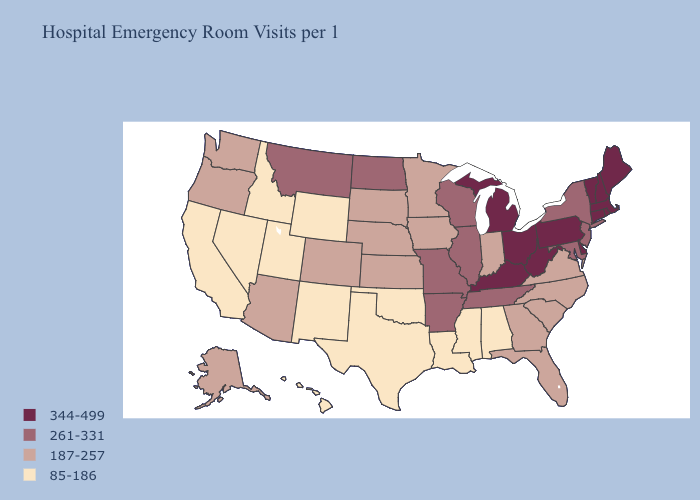Is the legend a continuous bar?
Be succinct. No. What is the value of Minnesota?
Answer briefly. 187-257. Does New York have the lowest value in the USA?
Quick response, please. No. Is the legend a continuous bar?
Quick response, please. No. Does the first symbol in the legend represent the smallest category?
Concise answer only. No. Does the first symbol in the legend represent the smallest category?
Short answer required. No. Name the states that have a value in the range 344-499?
Be succinct. Connecticut, Delaware, Kentucky, Maine, Massachusetts, Michigan, New Hampshire, Ohio, Pennsylvania, Rhode Island, Vermont, West Virginia. What is the value of Connecticut?
Quick response, please. 344-499. Does the map have missing data?
Give a very brief answer. No. Name the states that have a value in the range 187-257?
Concise answer only. Alaska, Arizona, Colorado, Florida, Georgia, Indiana, Iowa, Kansas, Minnesota, Nebraska, North Carolina, Oregon, South Carolina, South Dakota, Virginia, Washington. What is the highest value in states that border Massachusetts?
Write a very short answer. 344-499. What is the value of Kansas?
Be succinct. 187-257. Does Kansas have the lowest value in the USA?
Write a very short answer. No. Name the states that have a value in the range 344-499?
Concise answer only. Connecticut, Delaware, Kentucky, Maine, Massachusetts, Michigan, New Hampshire, Ohio, Pennsylvania, Rhode Island, Vermont, West Virginia. 